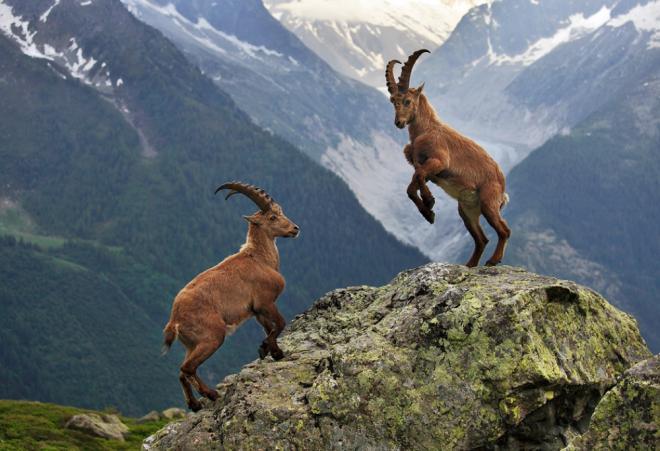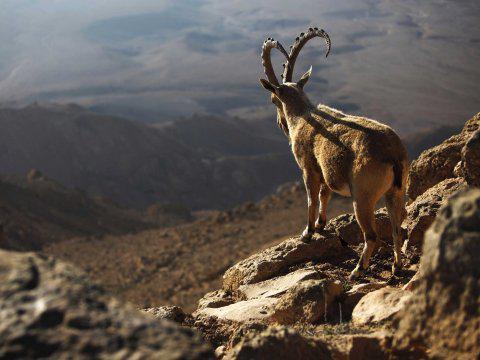The first image is the image on the left, the second image is the image on the right. For the images displayed, is the sentence "One picture only has one goat in it." factually correct? Answer yes or no. Yes. The first image is the image on the left, the second image is the image on the right. Examine the images to the left and right. Is the description "One image has more than one but less than three mountain goats." accurate? Answer yes or no. Yes. 